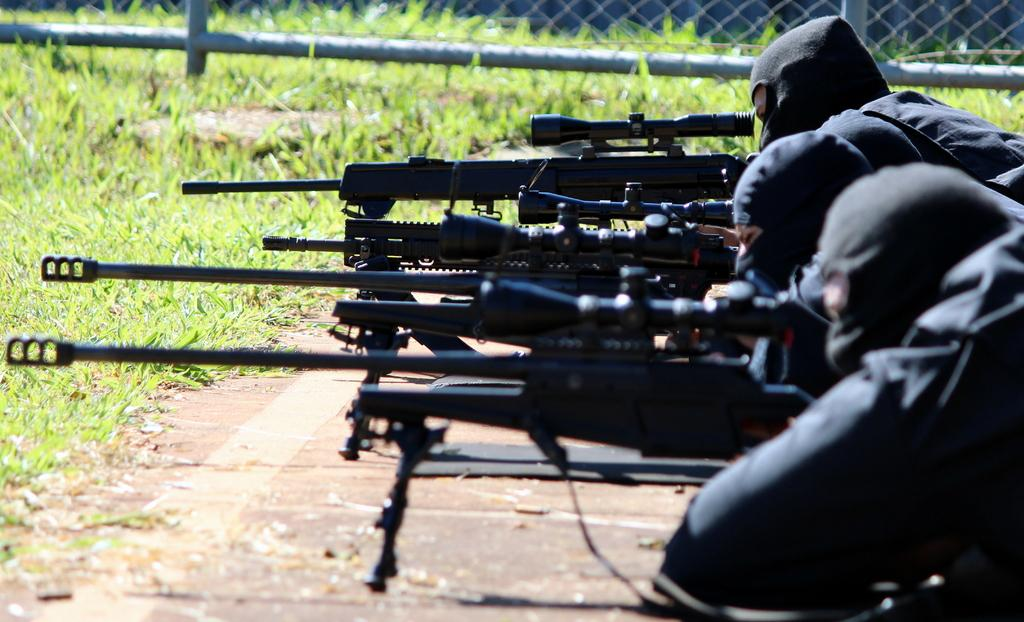Who or what can be seen in the image? There are people in the image. What are the people wearing on their faces? The people are wearing masks. What are the people holding in their hands? The people are holding guns. What type of barrier is present in the image? There is a fencing in the image. What type of vegetation can be seen in the image? There is grass and plants in the image. What is the price of the tin in the image? There is no tin present in the image, so it is not possible to determine its price. 